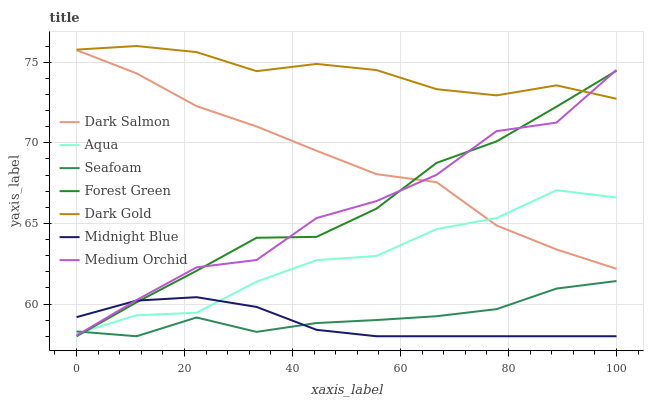Does Medium Orchid have the minimum area under the curve?
Answer yes or no. No. Does Medium Orchid have the maximum area under the curve?
Answer yes or no. No. Is Dark Gold the smoothest?
Answer yes or no. No. Is Dark Gold the roughest?
Answer yes or no. No. Does Medium Orchid have the lowest value?
Answer yes or no. No. Does Medium Orchid have the highest value?
Answer yes or no. No. Is Dark Salmon less than Dark Gold?
Answer yes or no. Yes. Is Dark Gold greater than Midnight Blue?
Answer yes or no. Yes. Does Dark Salmon intersect Dark Gold?
Answer yes or no. No. 